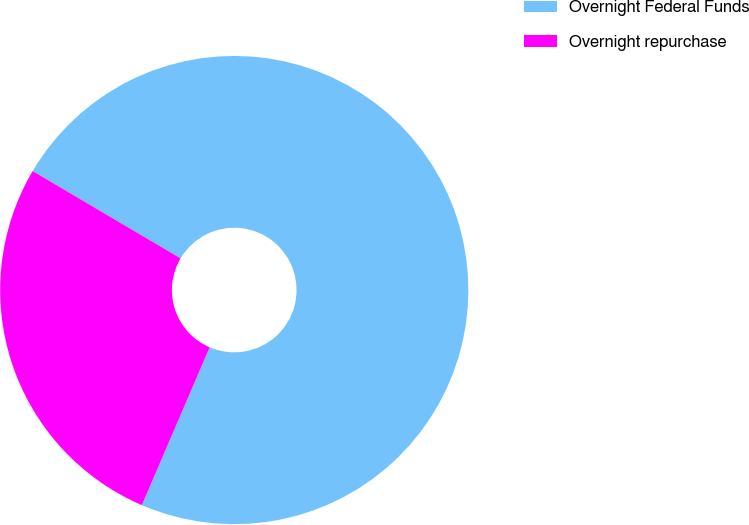Convert chart. <chart><loc_0><loc_0><loc_500><loc_500><pie_chart><fcel>Overnight Federal Funds<fcel>Overnight repurchase<nl><fcel>72.97%<fcel>27.03%<nl></chart> 